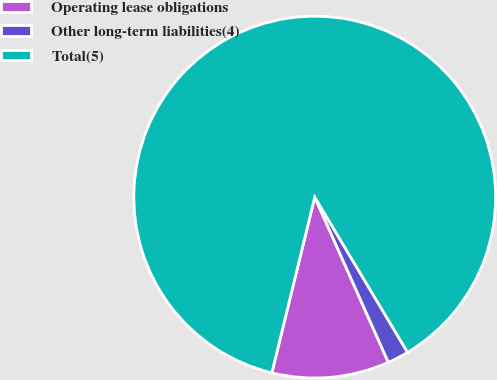<chart> <loc_0><loc_0><loc_500><loc_500><pie_chart><fcel>Operating lease obligations<fcel>Other long-term liabilities(4)<fcel>Total(5)<nl><fcel>10.48%<fcel>1.91%<fcel>87.61%<nl></chart> 